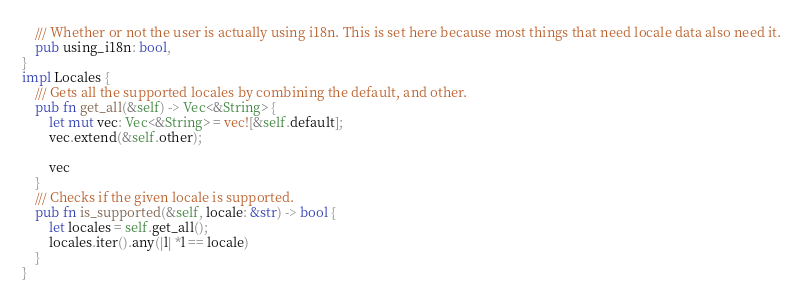Convert code to text. <code><loc_0><loc_0><loc_500><loc_500><_Rust_>    /// Whether or not the user is actually using i18n. This is set here because most things that need locale data also need it.
    pub using_i18n: bool,
}
impl Locales {
    /// Gets all the supported locales by combining the default, and other.
    pub fn get_all(&self) -> Vec<&String> {
        let mut vec: Vec<&String> = vec![&self.default];
        vec.extend(&self.other);

        vec
    }
    /// Checks if the given locale is supported.
    pub fn is_supported(&self, locale: &str) -> bool {
        let locales = self.get_all();
        locales.iter().any(|l| *l == locale)
    }
}
</code> 